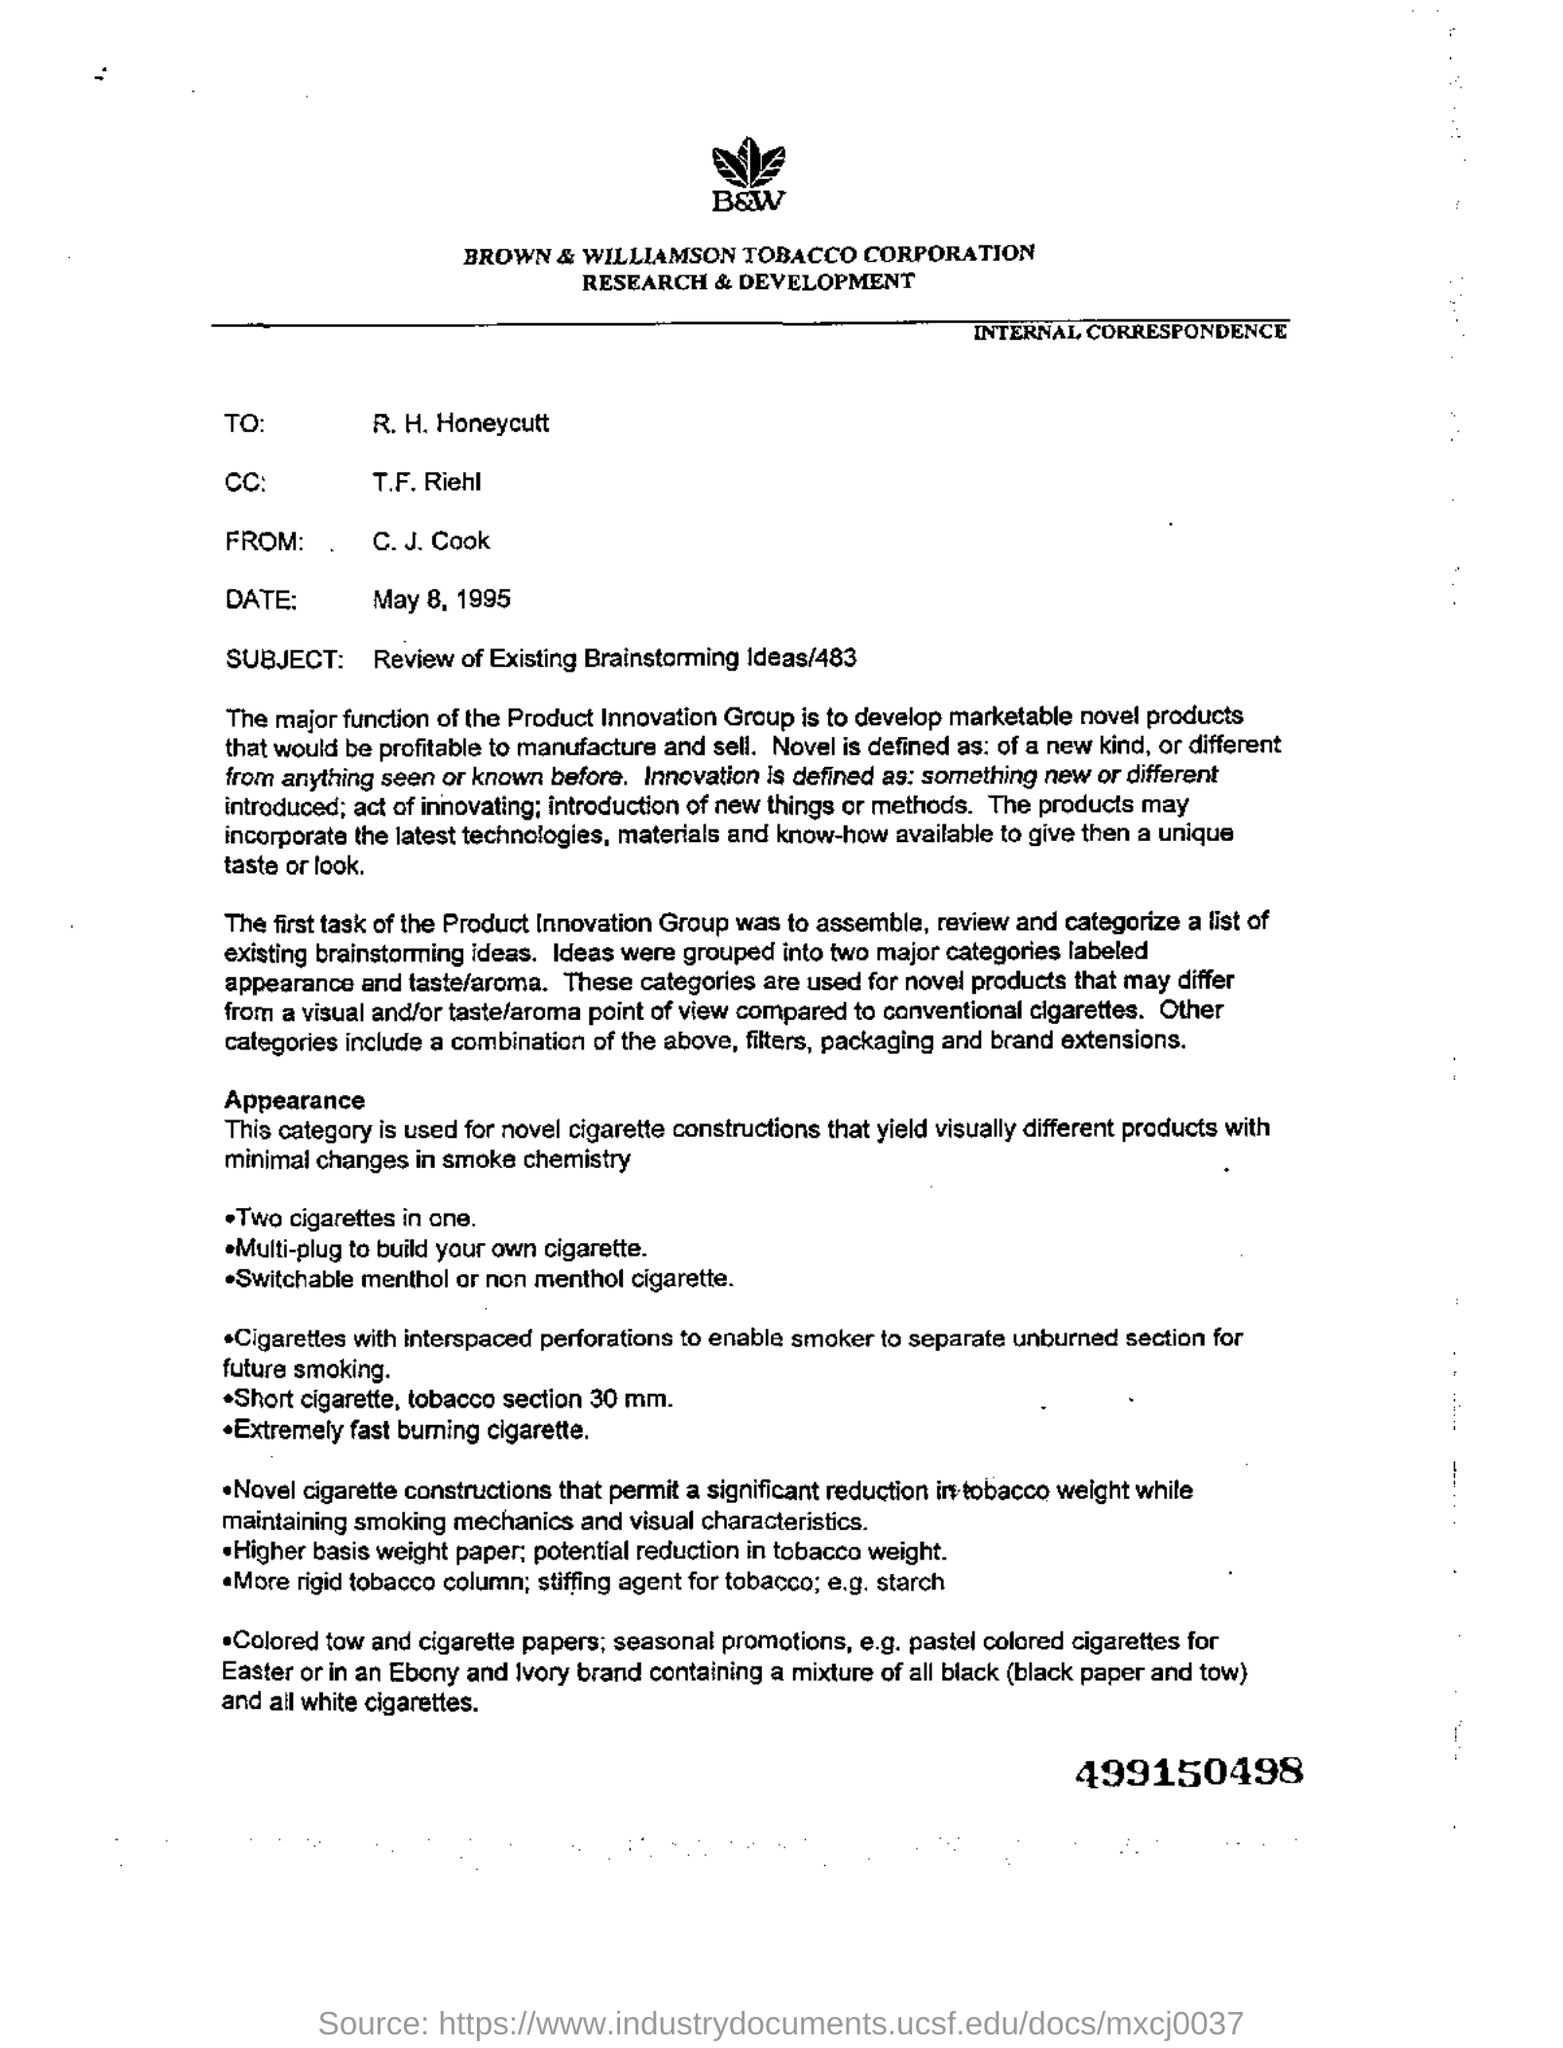Indicate a few pertinent items in this graphic. Below the logo, which appears as three leaves in black and white, is written. The letterhead in question is from Brown & Williamson Tobacco Corporation. The person who is cc in this letter is T.F. Riehl. The subject of this letter is the review of existing Brainstorming Ideas/483. The number at the bottom of the page is bold and is 499150498. 